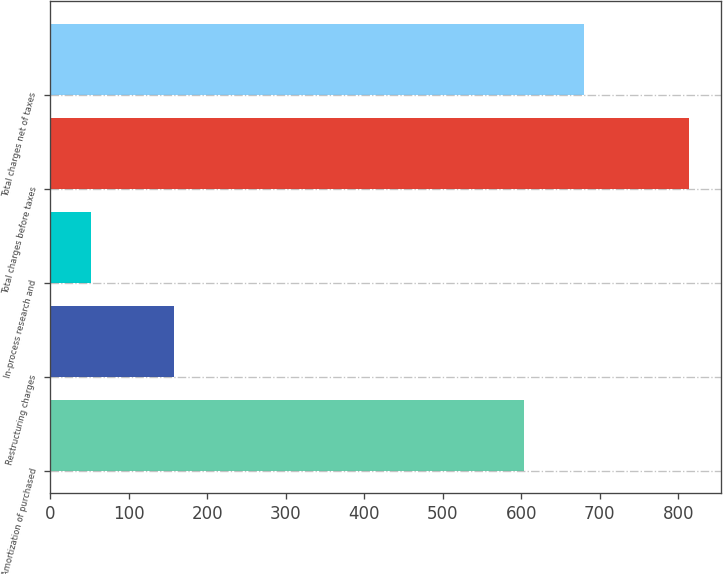<chart> <loc_0><loc_0><loc_500><loc_500><bar_chart><fcel>Amortization of purchased<fcel>Restructuring charges<fcel>In-process research and<fcel>Total charges before taxes<fcel>Total charges net of taxes<nl><fcel>604<fcel>158<fcel>52<fcel>814<fcel>680.2<nl></chart> 